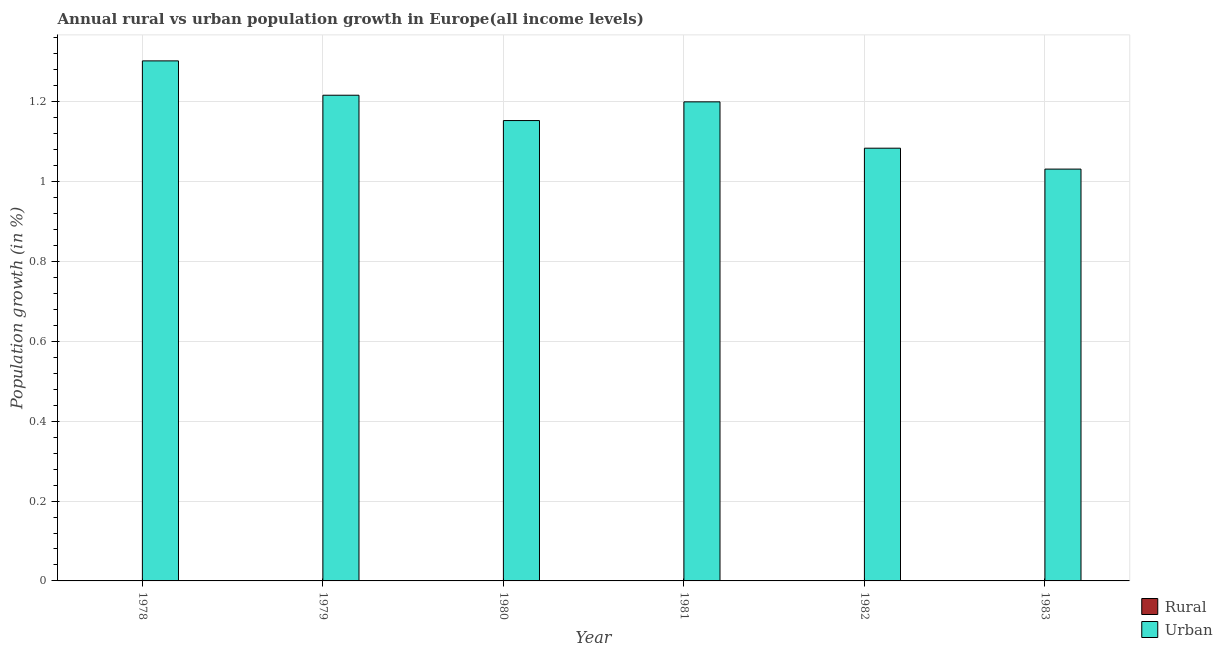How many different coloured bars are there?
Offer a very short reply. 1. Are the number of bars per tick equal to the number of legend labels?
Your answer should be compact. No. Are the number of bars on each tick of the X-axis equal?
Offer a very short reply. Yes. How many bars are there on the 5th tick from the left?
Give a very brief answer. 1. What is the label of the 1st group of bars from the left?
Ensure brevity in your answer.  1978. In how many cases, is the number of bars for a given year not equal to the number of legend labels?
Offer a very short reply. 6. What is the urban population growth in 1983?
Offer a very short reply. 1.03. Across all years, what is the maximum urban population growth?
Your answer should be compact. 1.3. Across all years, what is the minimum rural population growth?
Ensure brevity in your answer.  0. In which year was the urban population growth maximum?
Provide a short and direct response. 1978. What is the total urban population growth in the graph?
Your answer should be compact. 6.99. What is the difference between the urban population growth in 1980 and that in 1982?
Keep it short and to the point. 0.07. What is the difference between the urban population growth in 1981 and the rural population growth in 1983?
Offer a very short reply. 0.17. In the year 1983, what is the difference between the urban population growth and rural population growth?
Provide a succinct answer. 0. In how many years, is the urban population growth greater than 0.04 %?
Your response must be concise. 6. What is the ratio of the urban population growth in 1981 to that in 1983?
Your response must be concise. 1.16. What is the difference between the highest and the second highest urban population growth?
Keep it short and to the point. 0.09. What is the difference between the highest and the lowest urban population growth?
Offer a terse response. 0.27. In how many years, is the rural population growth greater than the average rural population growth taken over all years?
Your response must be concise. 0. Is the sum of the urban population growth in 1981 and 1982 greater than the maximum rural population growth across all years?
Give a very brief answer. Yes. How many bars are there?
Provide a succinct answer. 6. How many years are there in the graph?
Keep it short and to the point. 6. Are the values on the major ticks of Y-axis written in scientific E-notation?
Make the answer very short. No. How are the legend labels stacked?
Ensure brevity in your answer.  Vertical. What is the title of the graph?
Offer a terse response. Annual rural vs urban population growth in Europe(all income levels). What is the label or title of the X-axis?
Your answer should be compact. Year. What is the label or title of the Y-axis?
Your answer should be very brief. Population growth (in %). What is the Population growth (in %) in Rural in 1978?
Your response must be concise. 0. What is the Population growth (in %) of Urban  in 1978?
Provide a short and direct response. 1.3. What is the Population growth (in %) in Urban  in 1979?
Ensure brevity in your answer.  1.22. What is the Population growth (in %) in Urban  in 1980?
Offer a very short reply. 1.15. What is the Population growth (in %) of Urban  in 1981?
Your answer should be compact. 1.2. What is the Population growth (in %) of Urban  in 1982?
Ensure brevity in your answer.  1.08. What is the Population growth (in %) in Urban  in 1983?
Your answer should be very brief. 1.03. Across all years, what is the maximum Population growth (in %) in Urban ?
Offer a very short reply. 1.3. Across all years, what is the minimum Population growth (in %) in Urban ?
Ensure brevity in your answer.  1.03. What is the total Population growth (in %) of Rural in the graph?
Provide a short and direct response. 0. What is the total Population growth (in %) in Urban  in the graph?
Keep it short and to the point. 6.99. What is the difference between the Population growth (in %) in Urban  in 1978 and that in 1979?
Provide a succinct answer. 0.09. What is the difference between the Population growth (in %) in Urban  in 1978 and that in 1980?
Offer a very short reply. 0.15. What is the difference between the Population growth (in %) of Urban  in 1978 and that in 1981?
Ensure brevity in your answer.  0.1. What is the difference between the Population growth (in %) in Urban  in 1978 and that in 1982?
Offer a very short reply. 0.22. What is the difference between the Population growth (in %) in Urban  in 1978 and that in 1983?
Ensure brevity in your answer.  0.27. What is the difference between the Population growth (in %) of Urban  in 1979 and that in 1980?
Offer a very short reply. 0.06. What is the difference between the Population growth (in %) in Urban  in 1979 and that in 1981?
Ensure brevity in your answer.  0.02. What is the difference between the Population growth (in %) in Urban  in 1979 and that in 1982?
Make the answer very short. 0.13. What is the difference between the Population growth (in %) in Urban  in 1979 and that in 1983?
Give a very brief answer. 0.18. What is the difference between the Population growth (in %) in Urban  in 1980 and that in 1981?
Ensure brevity in your answer.  -0.05. What is the difference between the Population growth (in %) of Urban  in 1980 and that in 1982?
Offer a very short reply. 0.07. What is the difference between the Population growth (in %) of Urban  in 1980 and that in 1983?
Make the answer very short. 0.12. What is the difference between the Population growth (in %) in Urban  in 1981 and that in 1982?
Provide a succinct answer. 0.12. What is the difference between the Population growth (in %) of Urban  in 1981 and that in 1983?
Your answer should be very brief. 0.17. What is the difference between the Population growth (in %) of Urban  in 1982 and that in 1983?
Your response must be concise. 0.05. What is the average Population growth (in %) in Rural per year?
Your answer should be very brief. 0. What is the average Population growth (in %) in Urban  per year?
Your response must be concise. 1.16. What is the ratio of the Population growth (in %) of Urban  in 1978 to that in 1979?
Your response must be concise. 1.07. What is the ratio of the Population growth (in %) in Urban  in 1978 to that in 1980?
Offer a terse response. 1.13. What is the ratio of the Population growth (in %) of Urban  in 1978 to that in 1981?
Keep it short and to the point. 1.09. What is the ratio of the Population growth (in %) in Urban  in 1978 to that in 1982?
Provide a succinct answer. 1.2. What is the ratio of the Population growth (in %) of Urban  in 1978 to that in 1983?
Your answer should be compact. 1.26. What is the ratio of the Population growth (in %) in Urban  in 1979 to that in 1980?
Provide a short and direct response. 1.05. What is the ratio of the Population growth (in %) of Urban  in 1979 to that in 1981?
Provide a succinct answer. 1.01. What is the ratio of the Population growth (in %) of Urban  in 1979 to that in 1982?
Provide a succinct answer. 1.12. What is the ratio of the Population growth (in %) of Urban  in 1979 to that in 1983?
Provide a short and direct response. 1.18. What is the ratio of the Population growth (in %) of Urban  in 1980 to that in 1981?
Your answer should be very brief. 0.96. What is the ratio of the Population growth (in %) of Urban  in 1980 to that in 1982?
Ensure brevity in your answer.  1.06. What is the ratio of the Population growth (in %) of Urban  in 1980 to that in 1983?
Provide a succinct answer. 1.12. What is the ratio of the Population growth (in %) in Urban  in 1981 to that in 1982?
Ensure brevity in your answer.  1.11. What is the ratio of the Population growth (in %) in Urban  in 1981 to that in 1983?
Ensure brevity in your answer.  1.16. What is the ratio of the Population growth (in %) of Urban  in 1982 to that in 1983?
Your answer should be very brief. 1.05. What is the difference between the highest and the second highest Population growth (in %) in Urban ?
Your response must be concise. 0.09. What is the difference between the highest and the lowest Population growth (in %) in Urban ?
Make the answer very short. 0.27. 